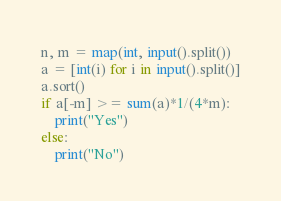Convert code to text. <code><loc_0><loc_0><loc_500><loc_500><_Python_>n, m = map(int, input().split())
a = [int(i) for i in input().split()]
a.sort()
if a[-m] >= sum(a)*1/(4*m):
    print("Yes")
else:
    print("No")</code> 